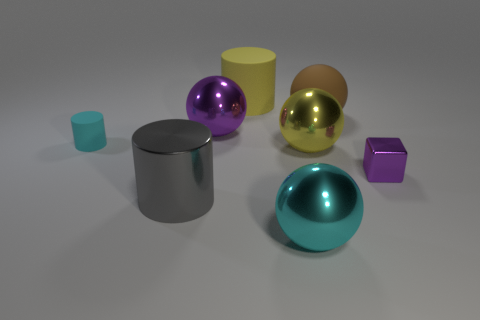There is a yellow shiny thing that is the same shape as the large cyan thing; what is its size?
Your answer should be very brief. Large. Do the ball in front of the purple cube and the yellow object behind the cyan cylinder have the same material?
Ensure brevity in your answer.  No. Is the number of large purple shiny things that are on the left side of the big gray metallic cylinder less than the number of big matte cylinders?
Provide a succinct answer. Yes. Is there any other thing that has the same shape as the gray object?
Keep it short and to the point. Yes. What is the color of the other large matte object that is the same shape as the big cyan thing?
Keep it short and to the point. Brown. Is the size of the purple shiny thing on the right side of the cyan metallic sphere the same as the big brown matte ball?
Keep it short and to the point. No. There is a metallic object that is on the left side of the purple object to the left of the purple shiny block; what is its size?
Give a very brief answer. Large. Do the tiny cyan cylinder and the purple thing on the left side of the big rubber cylinder have the same material?
Your answer should be very brief. No. Is the number of tiny purple things left of the tiny rubber cylinder less than the number of purple objects that are behind the large yellow metal thing?
Provide a succinct answer. Yes. What is the color of the big thing that is the same material as the brown ball?
Your answer should be very brief. Yellow. 